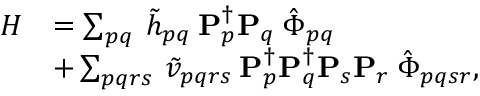<formula> <loc_0><loc_0><loc_500><loc_500>\begin{array} { r l } { H } & { = \sum _ { p q } \, \tilde { h } _ { p q } \, P _ { p } ^ { \dagger } P _ { q } \, \hat { \Phi } _ { p q } } \\ & { + \sum _ { p q r s } \, \tilde { v } _ { p q r s } \, P _ { p } ^ { \dagger } P _ { q } ^ { \dagger } P _ { s } P _ { r } \, \hat { \Phi } _ { p q s r } , } \end{array}</formula> 